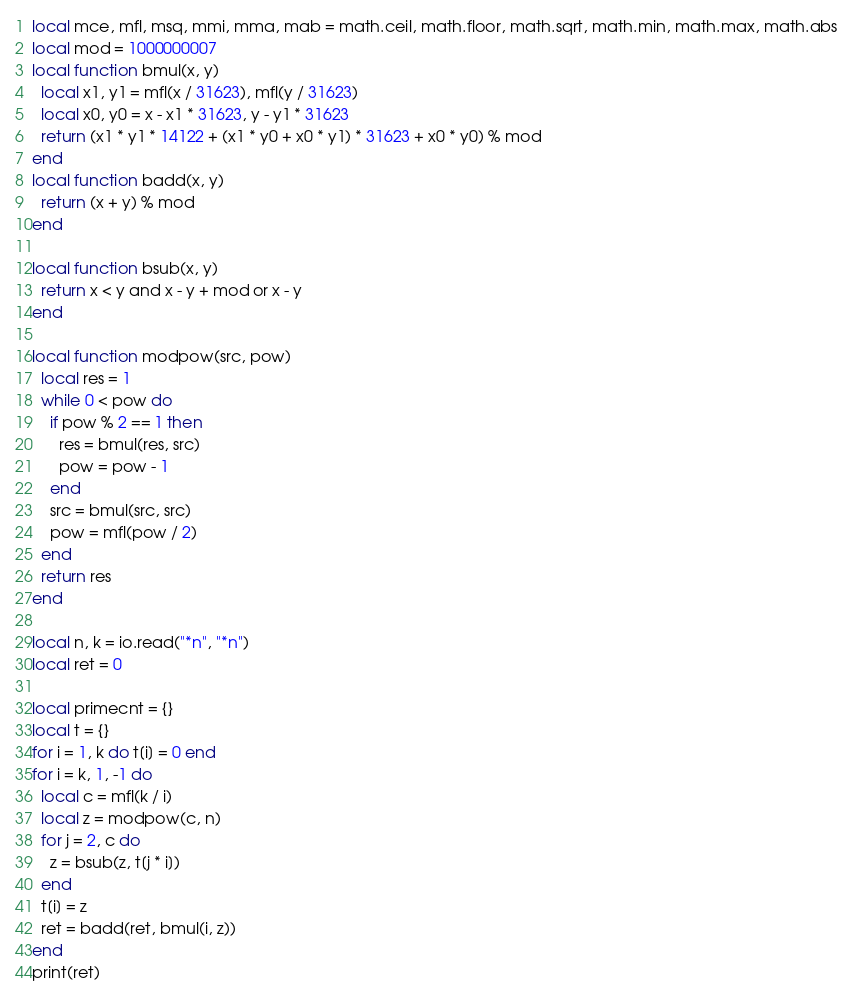Convert code to text. <code><loc_0><loc_0><loc_500><loc_500><_Lua_>local mce, mfl, msq, mmi, mma, mab = math.ceil, math.floor, math.sqrt, math.min, math.max, math.abs
local mod = 1000000007
local function bmul(x, y)
  local x1, y1 = mfl(x / 31623), mfl(y / 31623)
  local x0, y0 = x - x1 * 31623, y - y1 * 31623
  return (x1 * y1 * 14122 + (x1 * y0 + x0 * y1) * 31623 + x0 * y0) % mod
end
local function badd(x, y)
  return (x + y) % mod
end

local function bsub(x, y)
  return x < y and x - y + mod or x - y
end

local function modpow(src, pow)
  local res = 1
  while 0 < pow do
    if pow % 2 == 1 then
      res = bmul(res, src)
      pow = pow - 1
    end
    src = bmul(src, src)
    pow = mfl(pow / 2)
  end
  return res
end

local n, k = io.read("*n", "*n")
local ret = 0

local primecnt = {}
local t = {}
for i = 1, k do t[i] = 0 end
for i = k, 1, -1 do
  local c = mfl(k / i)
  local z = modpow(c, n)
  for j = 2, c do
    z = bsub(z, t[j * i])
  end
  t[i] = z
  ret = badd(ret, bmul(i, z))
end
print(ret)
</code> 